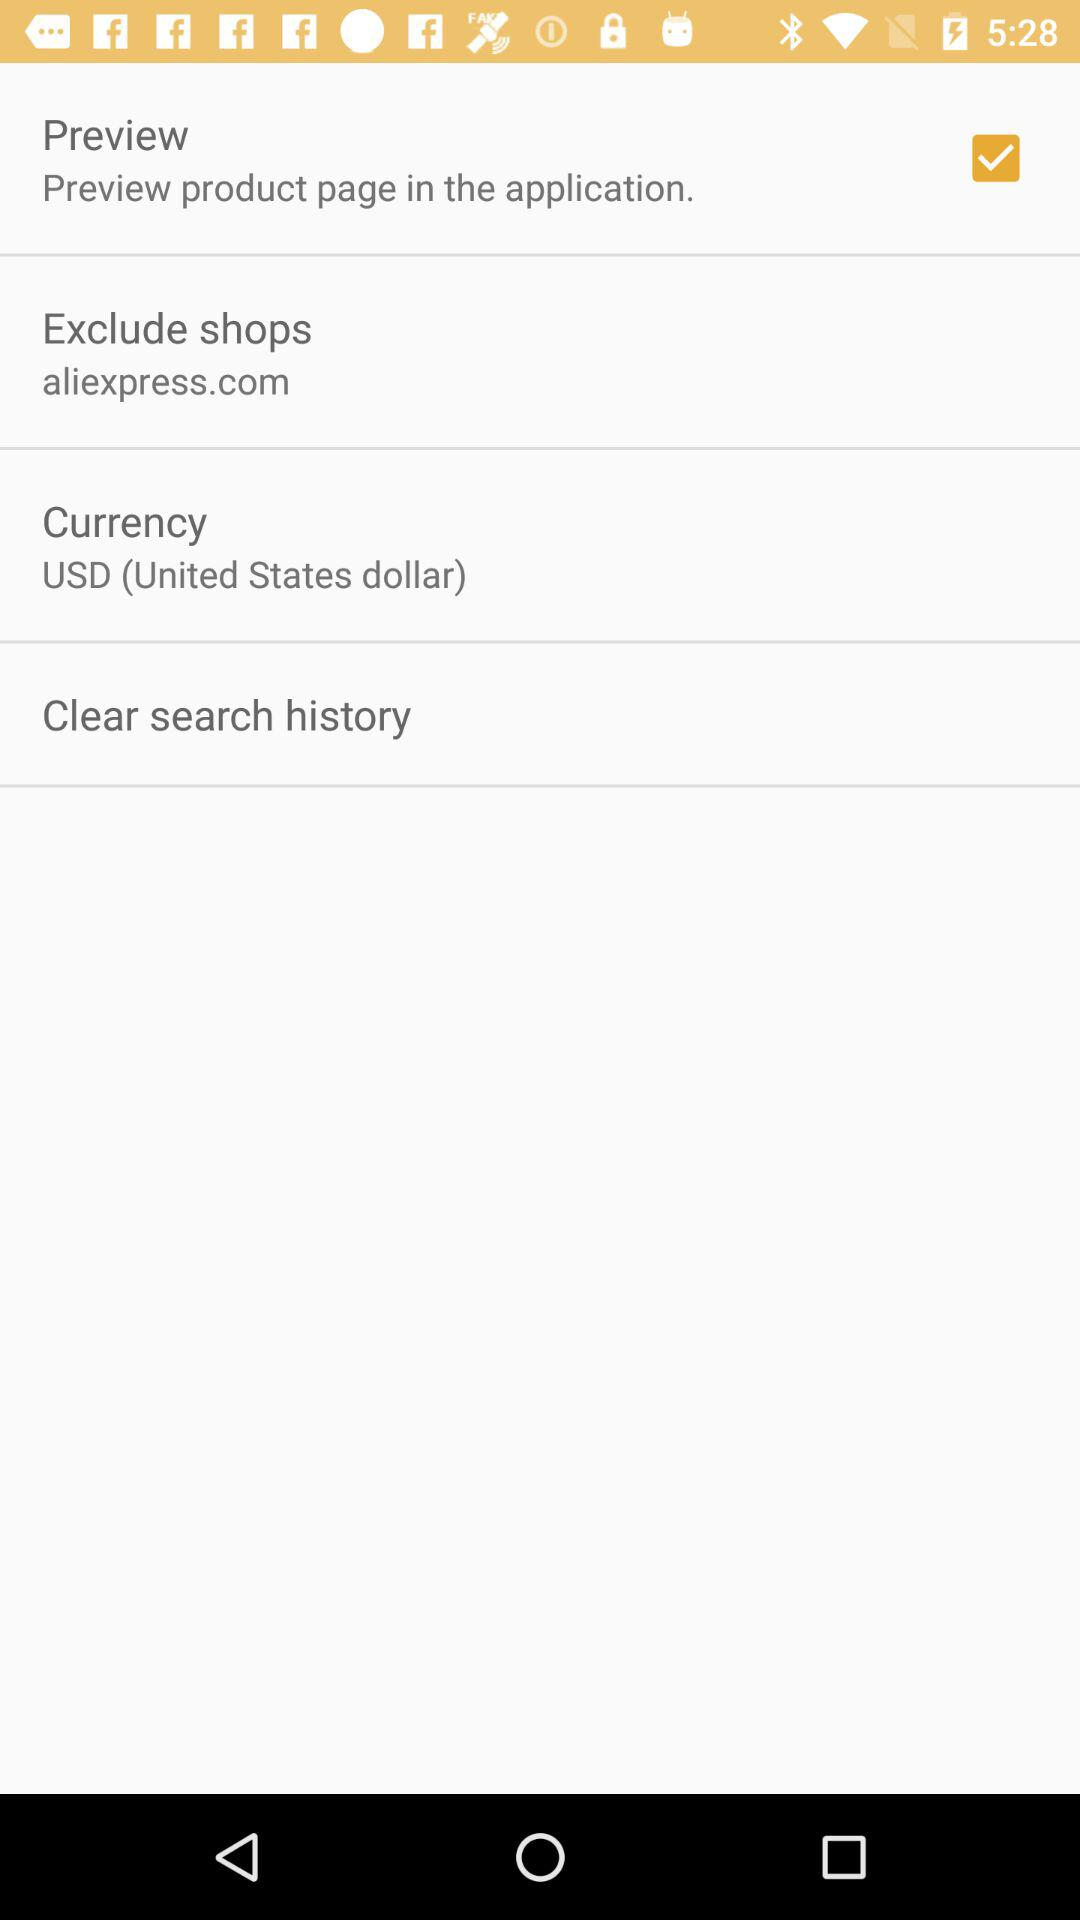Has the history been cleared?
When the provided information is insufficient, respond with <no answer>. <no answer> 